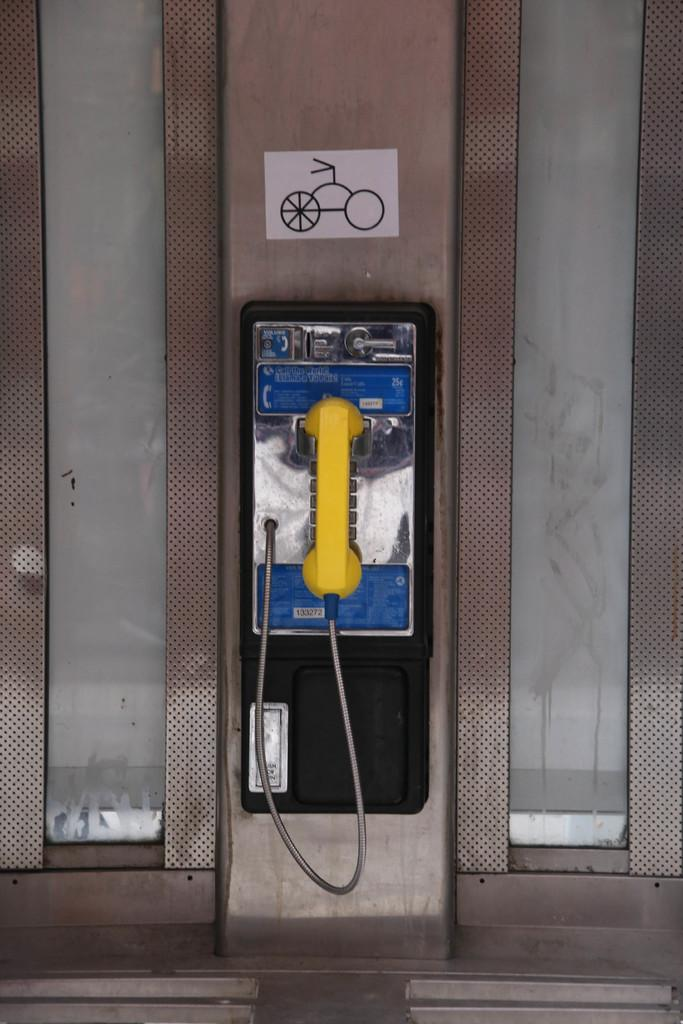What is present on the wall in the image? There is a phone, a board, and a label attached to the wall in the image. Can you describe the phone on the wall? The phone on the wall is a device used for communication. What is the purpose of the board attached to the wall? The purpose of the board attached to the wall is not specified in the image, but it could be used for displaying information or notes. What is the label attached to the wall used for? The label attached to the wall might be used for identification or organization purposes. How many cars are parked in front of the wall in the image? There are no cars visible in the image; it only shows a wall with a phone, a board, and a label attached to it. 